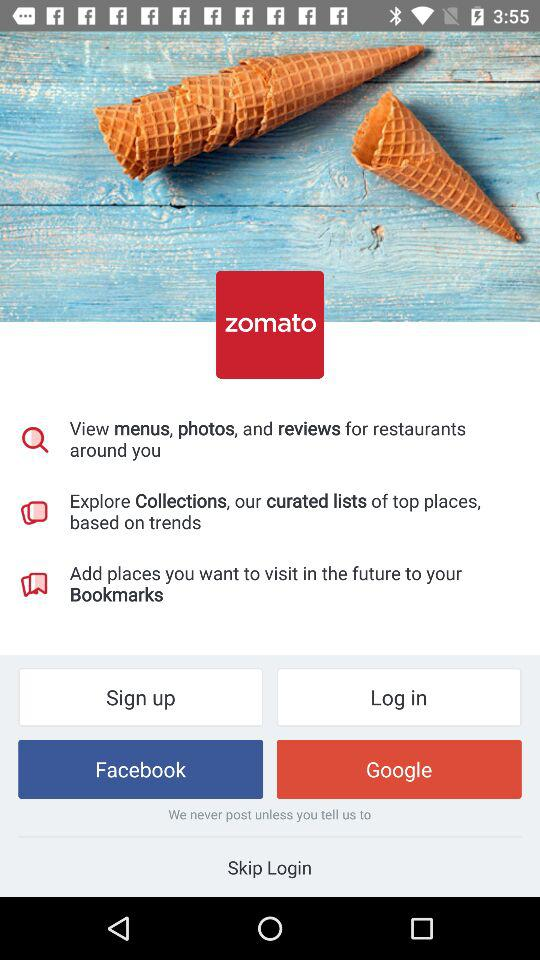What is the application name? The application name is "zomato". 